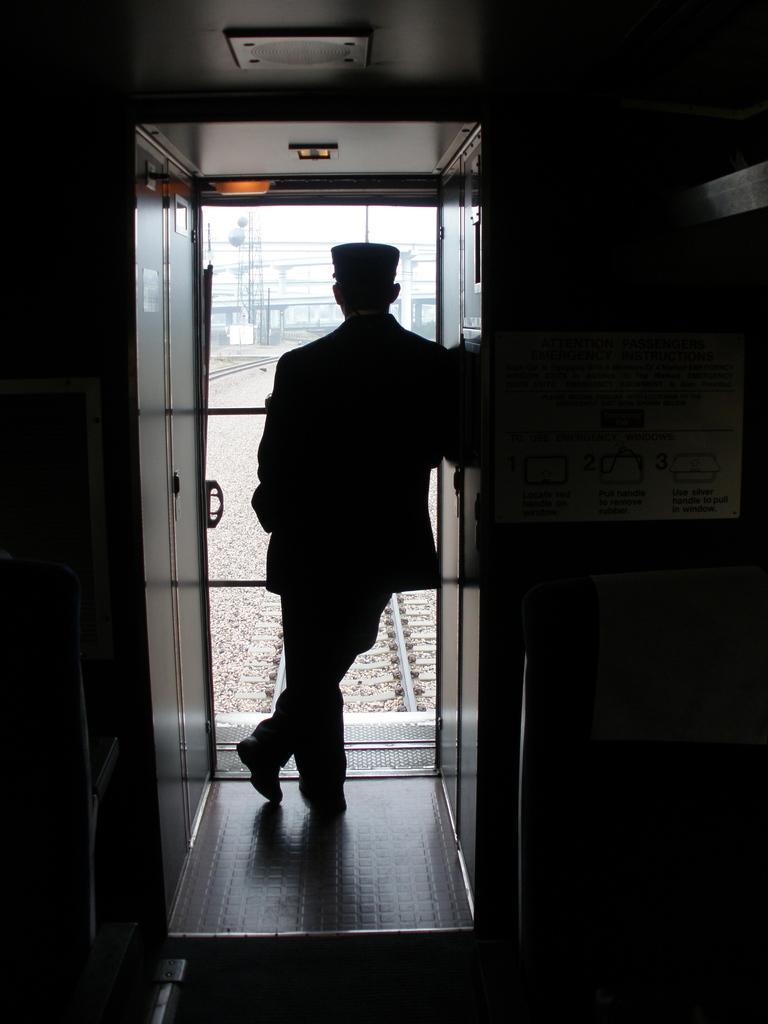Describe this image in one or two sentences. In this image I can see a person standing, background I can see a door and few poles, few tracks, trees and the sky is in white color. 